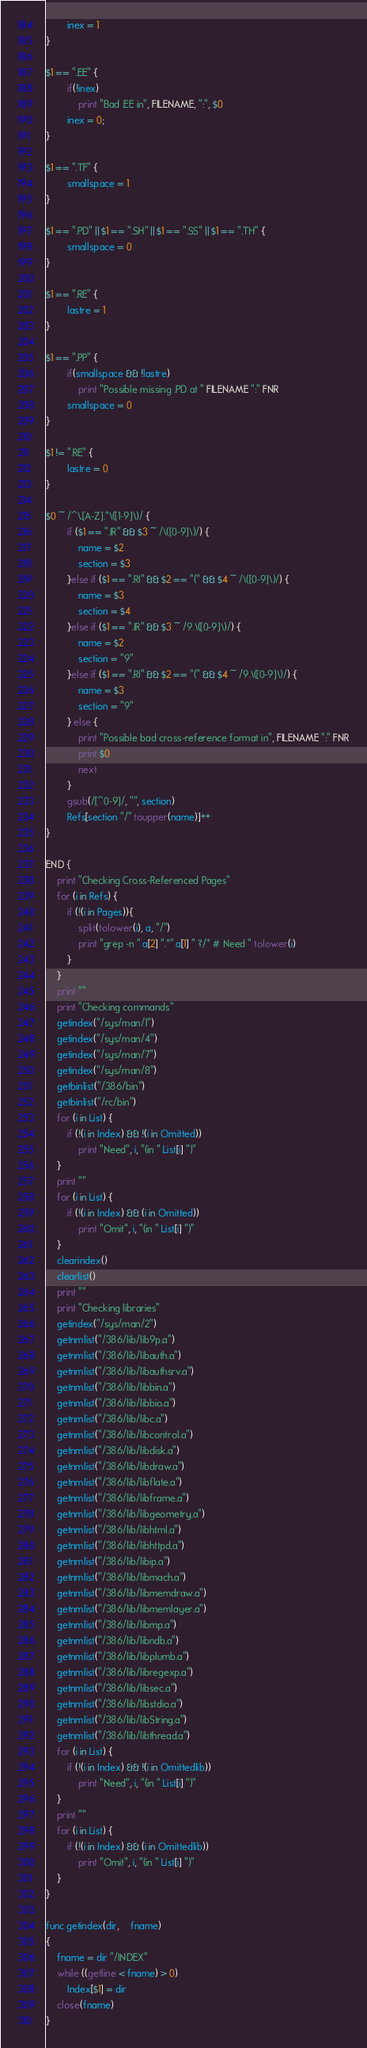<code> <loc_0><loc_0><loc_500><loc_500><_Awk_>		inex = 1
}

$1 == ".EE" {
		if(!inex)
			print "Bad .EE in", FILENAME, ":", $0
		inex = 0;
}

$1 == ".TF" {
		smallspace = 1
}

$1 == ".PD" || $1 == ".SH" || $1 == ".SS" || $1 == ".TH" {
		smallspace = 0
}

$1 == ".RE" {
		lastre = 1
}

$1 == ".PP" {
		if(smallspace && !lastre)
			print "Possible missing .PD at " FILENAME ":" FNR
		smallspace = 0
}

$1 != ".RE" {
		lastre = 0
}

$0 ~ /^\.[A-Z].*\([1-9]\)/ {
		if ($1 == ".IR" && $3 ~ /\([0-9]\)/) {
			name = $2
			section = $3
		}else if ($1 == ".RI" && $2 == "(" && $4 ~ /\([0-9]\)/) {
			name = $3
			section = $4
		}else if ($1 == ".IR" && $3 ~ /9.\([0-9]\)/) {
			name = $2
			section = "9"
		}else if ($1 == ".RI" && $2 == "(" && $4 ~ /9.\([0-9]\)/) {
			name = $3
			section = "9"
		} else {
			print "Possible bad cross-reference format in", FILENAME ":" FNR
			print $0
			next
		}
		gsub(/[^0-9]/, "", section)
		Refs[section "/" toupper(name)]++
}

END {
	print "Checking Cross-Referenced Pages"
	for (i in Refs) {
		if (!(i in Pages)){
			split(tolower(i), a, "/")
			print "grep -n " a[2] ".*" a[1] " ?/* # Need " tolower(i)
		}
	}
	print ""
	print "Checking commands"
	getindex("/sys/man/1")
	getindex("/sys/man/4")
	getindex("/sys/man/7")
	getindex("/sys/man/8")
	getbinlist("/386/bin")
	getbinlist("/rc/bin")
	for (i in List) {
		if (!(i in Index) && !(i in Omitted))
			print "Need", i, "(in " List[i] ")"
	}
	print ""
	for (i in List) {
		if (!(i in Index) && (i in Omitted))
			print "Omit", i, "(in " List[i] ")"
	}
	clearindex()
	clearlist()
	print ""
	print "Checking libraries"
	getindex("/sys/man/2")
	getnmlist("/386/lib/lib9p.a")
	getnmlist("/386/lib/libauth.a")
	getnmlist("/386/lib/libauthsrv.a")
	getnmlist("/386/lib/libbin.a")
	getnmlist("/386/lib/libbio.a")
	getnmlist("/386/lib/libc.a")
	getnmlist("/386/lib/libcontrol.a")
	getnmlist("/386/lib/libdisk.a")
	getnmlist("/386/lib/libdraw.a")
	getnmlist("/386/lib/libflate.a")
	getnmlist("/386/lib/libframe.a")
	getnmlist("/386/lib/libgeometry.a")
	getnmlist("/386/lib/libhtml.a")
	getnmlist("/386/lib/libhttpd.a")
	getnmlist("/386/lib/libip.a")
	getnmlist("/386/lib/libmach.a")
	getnmlist("/386/lib/libmemdraw.a")
	getnmlist("/386/lib/libmemlayer.a")
	getnmlist("/386/lib/libmp.a")
	getnmlist("/386/lib/libndb.a")
	getnmlist("/386/lib/libplumb.a")
	getnmlist("/386/lib/libregexp.a")
	getnmlist("/386/lib/libsec.a")
	getnmlist("/386/lib/libstdio.a")
	getnmlist("/386/lib/libString.a")
	getnmlist("/386/lib/libthread.a")
	for (i in List) {
		if (!(i in Index) && !(i in Omittedlib))
			print "Need", i, "(in " List[i] ")"
	}
	print ""
	for (i in List) {
		if (!(i in Index) && (i in Omittedlib))
			print "Omit", i, "(in " List[i] ")"
	}
}

func getindex(dir,    fname)
{
	fname = dir "/INDEX"
	while ((getline < fname) > 0)
		Index[$1] = dir
	close(fname)
}
</code> 